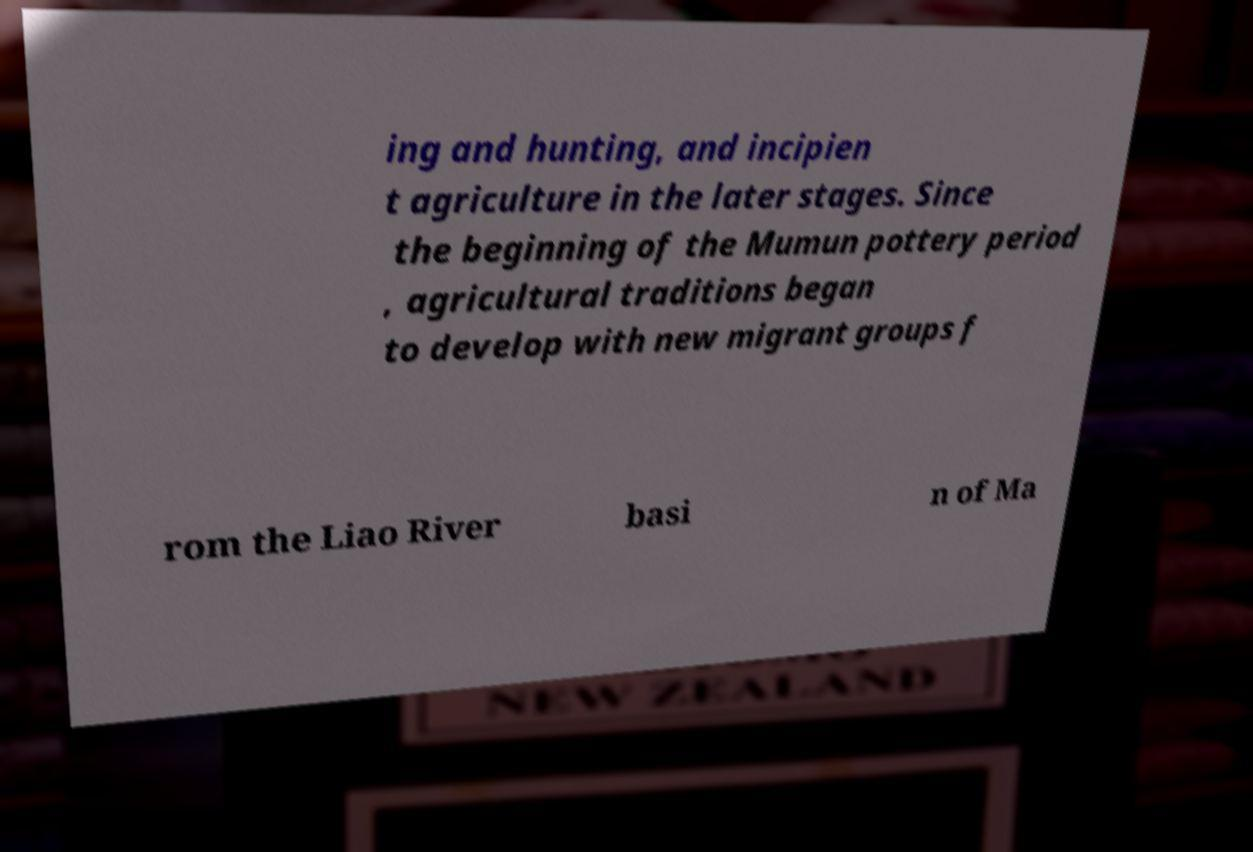For documentation purposes, I need the text within this image transcribed. Could you provide that? ing and hunting, and incipien t agriculture in the later stages. Since the beginning of the Mumun pottery period , agricultural traditions began to develop with new migrant groups f rom the Liao River basi n of Ma 